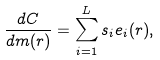Convert formula to latex. <formula><loc_0><loc_0><loc_500><loc_500>\frac { d C } { d m ( r ) } = \sum _ { i = 1 } ^ { L } s _ { i } e _ { i } ( r ) ,</formula> 